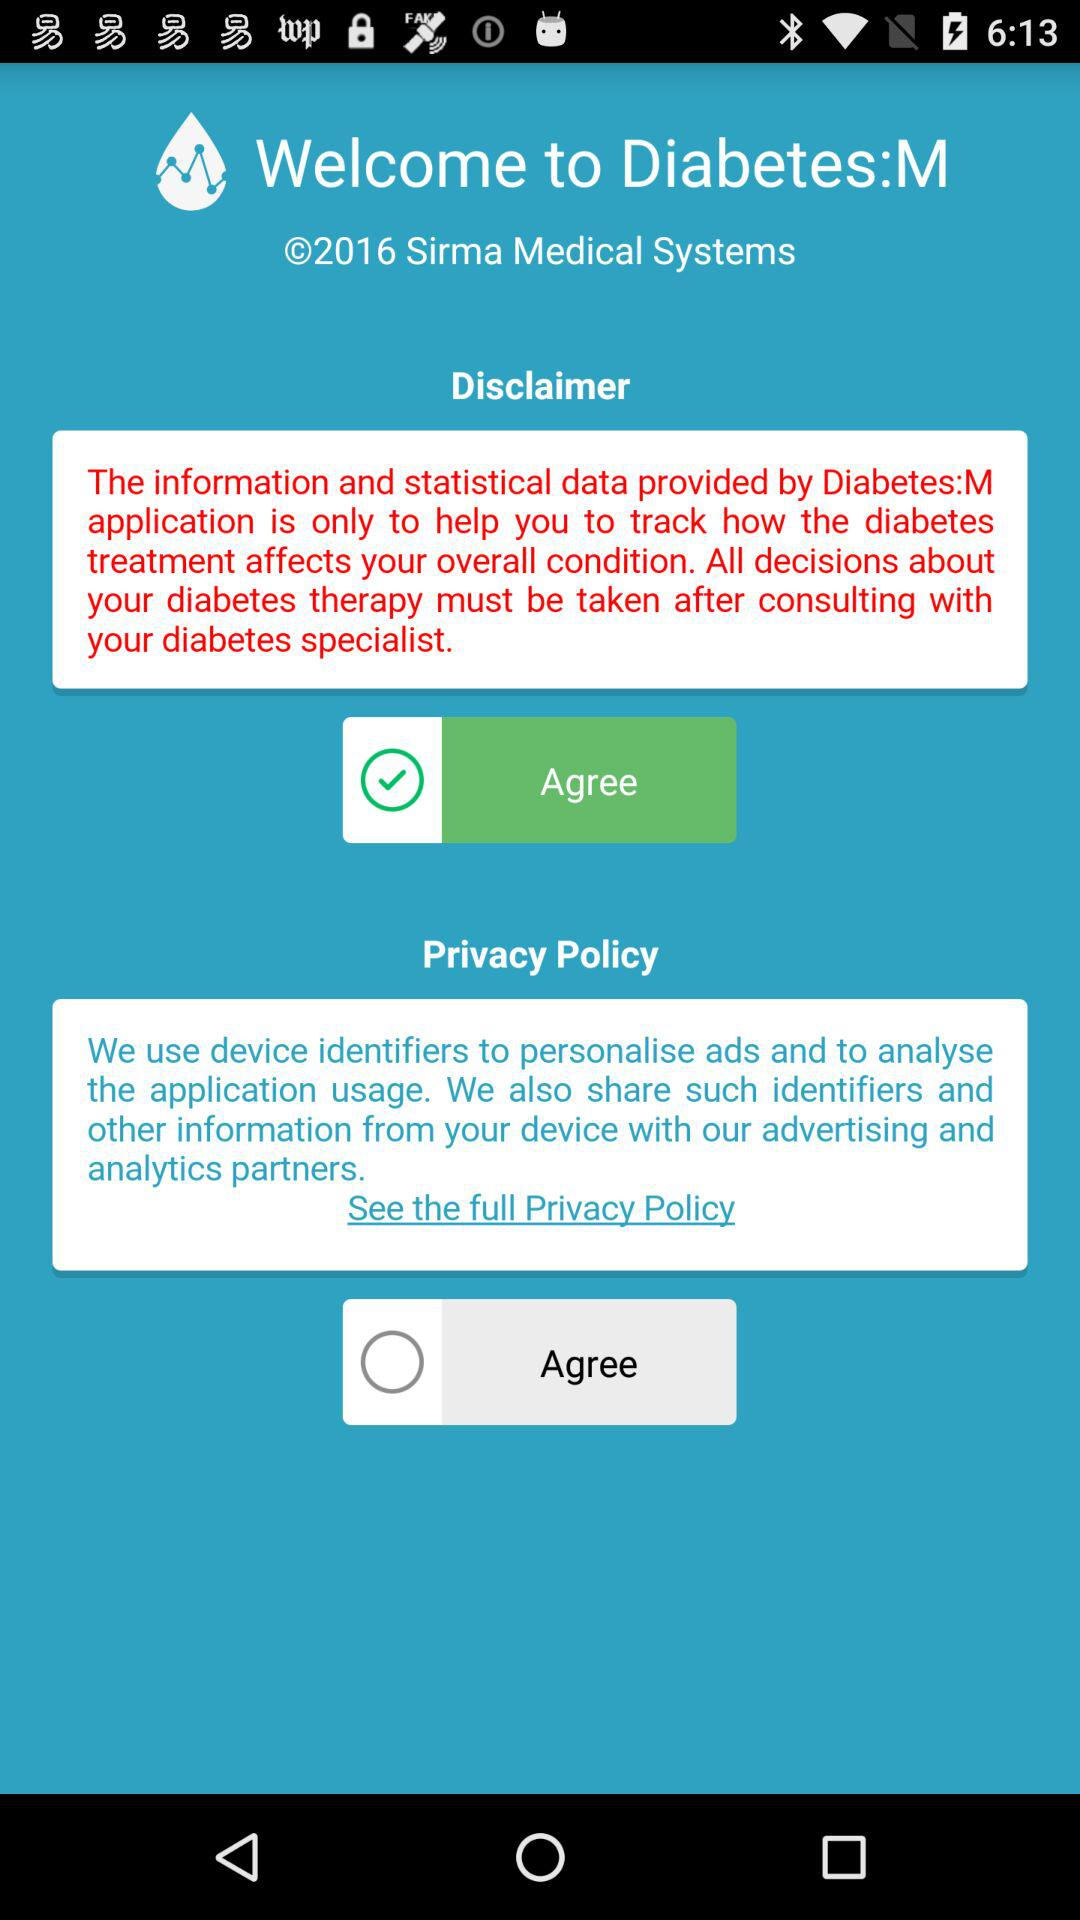What is the application name? The application name is "Diabetes:M". 